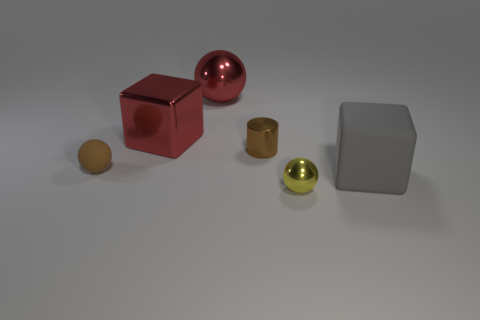How might the sizes of these objects compare to everyday items we are familiar with? The sizes of these objects can be related to common household items: the large red cube is roughly the size of a small footstool, the brown matte ball is comparable to a grapefruit, the metallic cylindrical objects could be likened to kitchen canisters, and the reflective balls might be the size of large apples. 